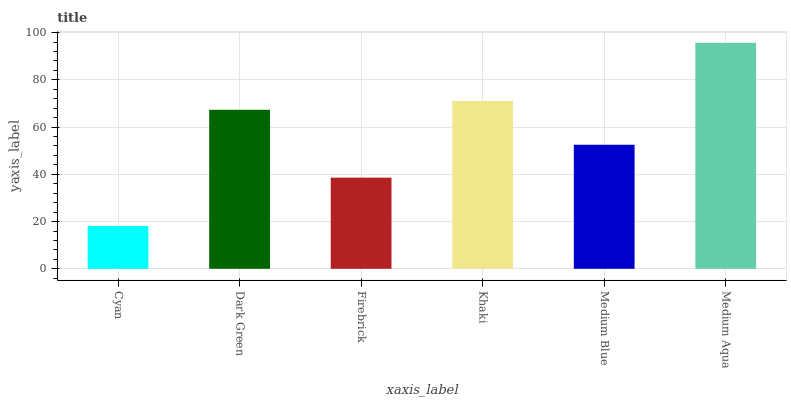Is Cyan the minimum?
Answer yes or no. Yes. Is Medium Aqua the maximum?
Answer yes or no. Yes. Is Dark Green the minimum?
Answer yes or no. No. Is Dark Green the maximum?
Answer yes or no. No. Is Dark Green greater than Cyan?
Answer yes or no. Yes. Is Cyan less than Dark Green?
Answer yes or no. Yes. Is Cyan greater than Dark Green?
Answer yes or no. No. Is Dark Green less than Cyan?
Answer yes or no. No. Is Dark Green the high median?
Answer yes or no. Yes. Is Medium Blue the low median?
Answer yes or no. Yes. Is Medium Aqua the high median?
Answer yes or no. No. Is Medium Aqua the low median?
Answer yes or no. No. 